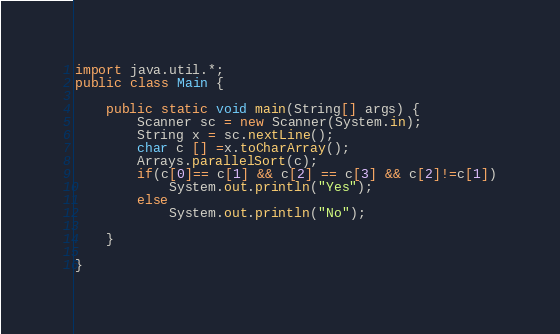Convert code to text. <code><loc_0><loc_0><loc_500><loc_500><_Java_>import java.util.*;
public class Main {

	public static void main(String[] args) {
		Scanner sc = new Scanner(System.in);
		String x = sc.nextLine();
		char c [] =x.toCharArray();
		Arrays.parallelSort(c);
		if(c[0]== c[1] && c[2] == c[3] && c[2]!=c[1])
			System.out.println("Yes");
		else 
			System.out.println("No");

	}

}
</code> 